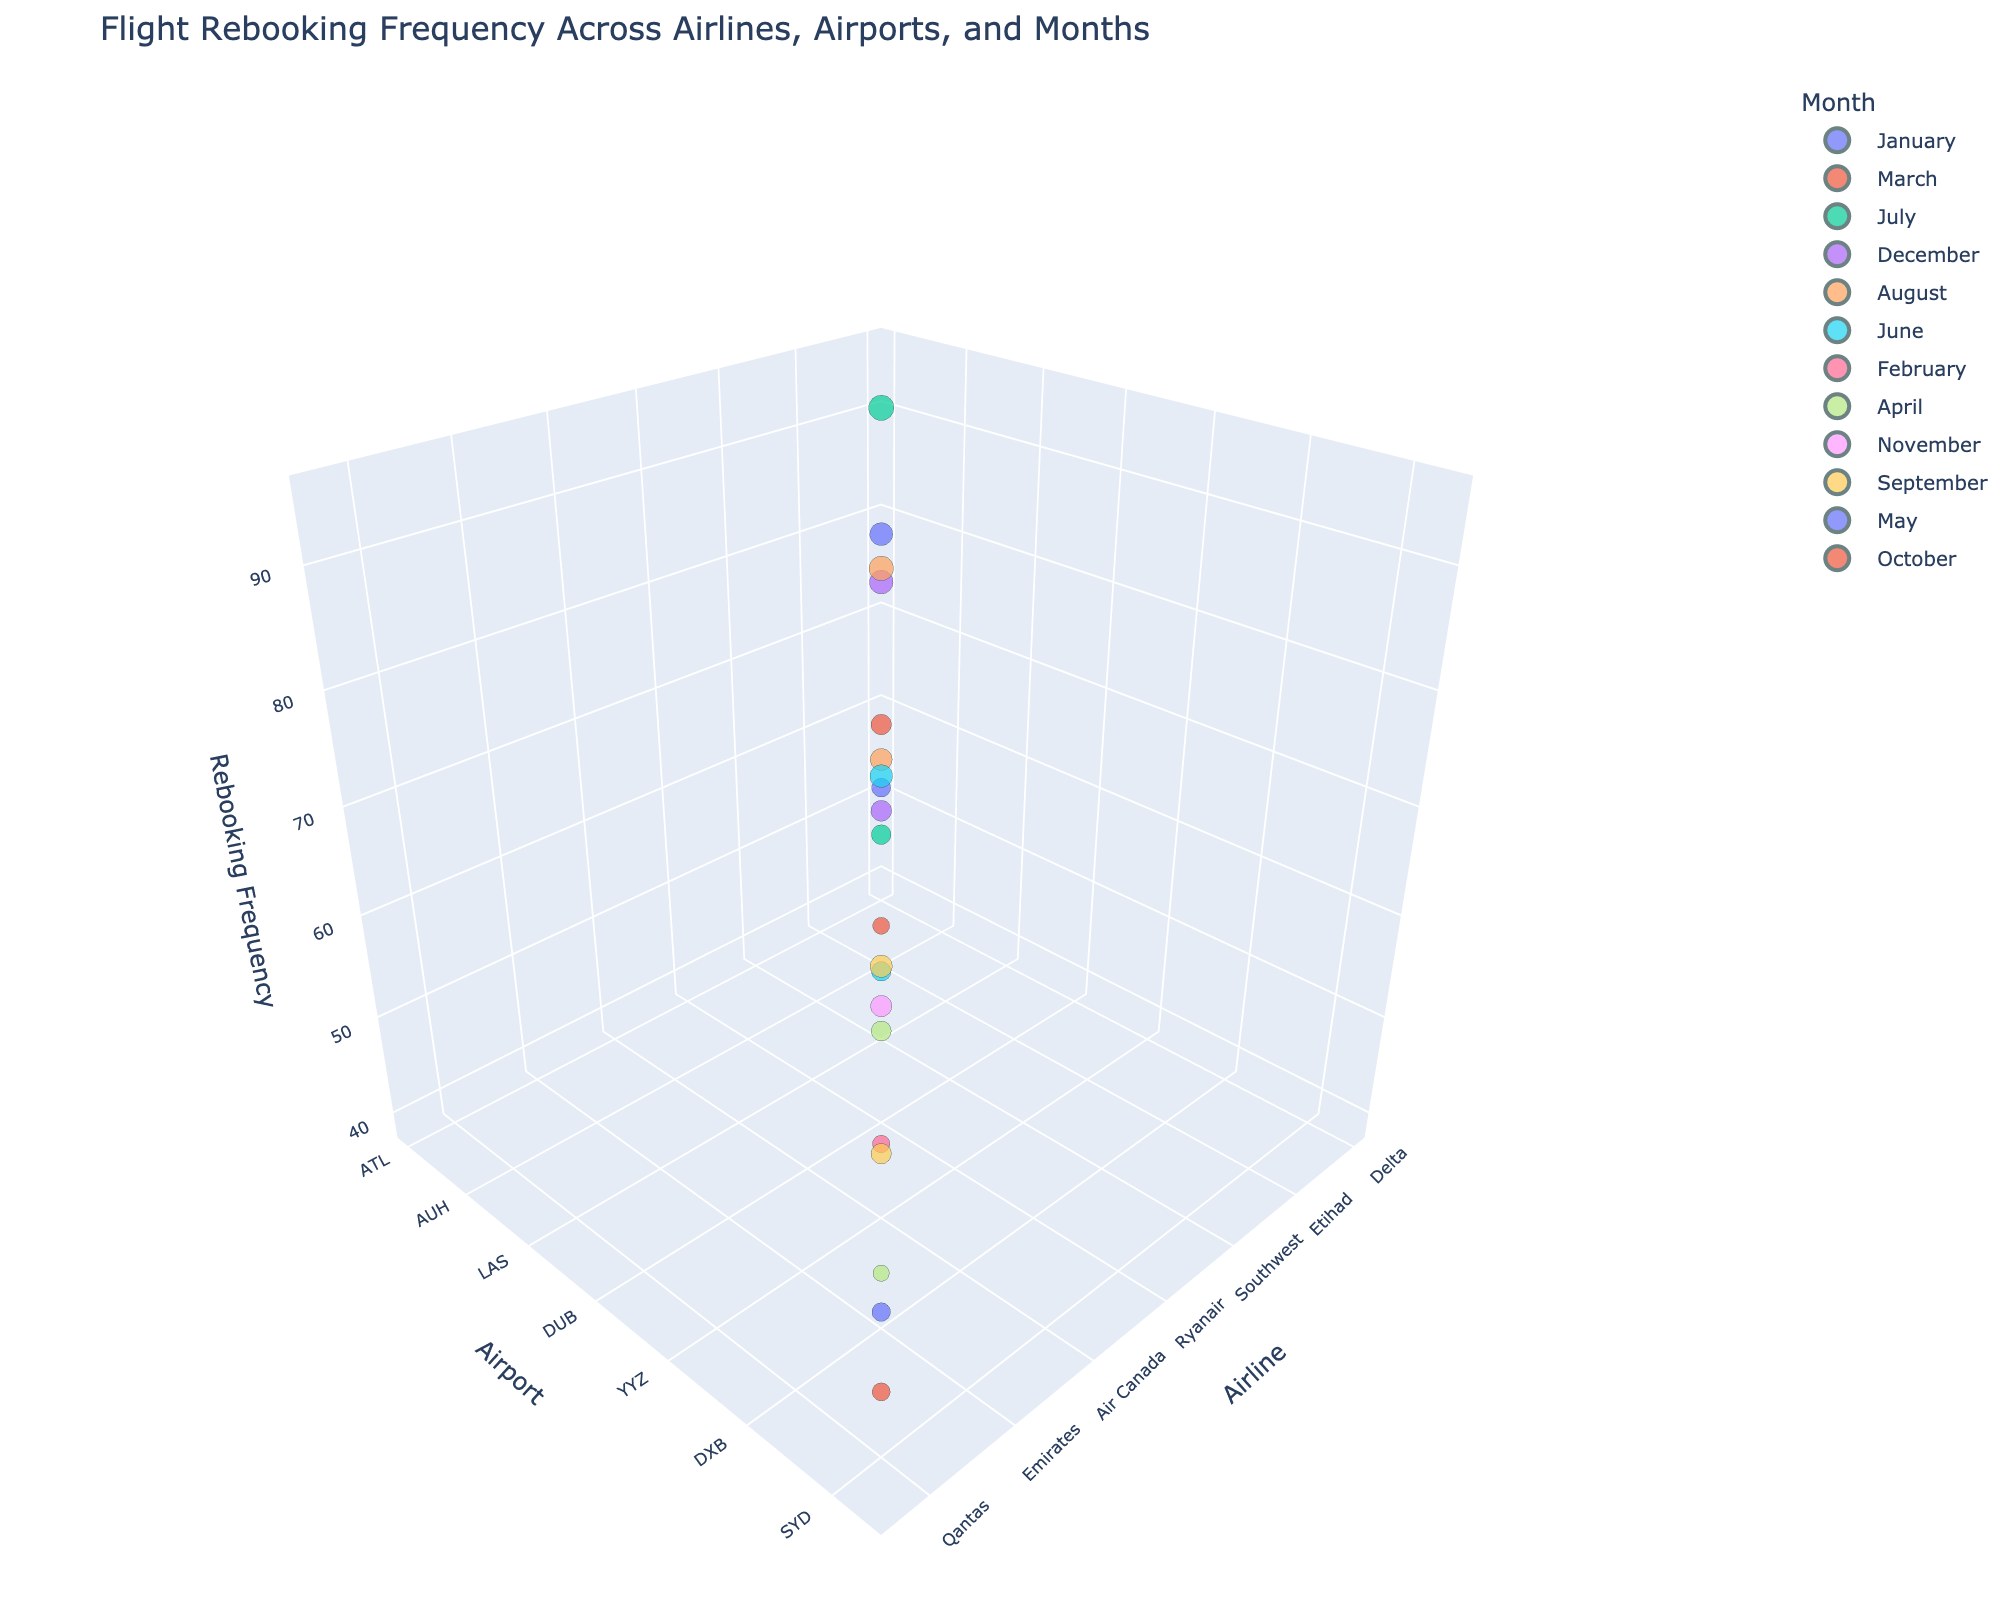How many data points are representing flight rebooking frequencies in the plot? There are 19 rows in the dataset provided, each representing a unique combination of Airline, Airport, Month, and RebookingFrequency. So, there are 19 data points in total in the plot.
Answer: 19 Which airline has the highest rebooking frequency? By inspecting the z-axis (Rebooking Frequency) in the 3D scatter plot, the highest point on this axis represents the highest rebooking frequency. American Airlines has the highest rebooking frequency at 95 in July at DFW Airport.
Answer: American What is the rebooking frequency for Emirates at DXB in November? By locating Emirates on the x-axis, DXB on the y-axis, and adjusting the view to see the z-axis value for November, we find the rebooking frequency is 67.
Answer: 67 Which airline and airport combination shows the lowest rebooking frequency? By looking for the lowest point on the z-axis (Rebooking Frequency), we see that Avianca at BOG Airport in April has the lowest rebooking frequency at 39.
Answer: Avianca at BOG What is the total rebooking frequency for flights operated by Delta and American combined? To find the total rebooking frequency, sum the RebookingFrequency values for Delta (78) and American (95). The total is 78 + 95 = 173.
Answer: 173 Between January and December, which month shows a higher number of airlines with high rebooking frequencies (greater than 70)? By counting the number of airlines with rebooking frequencies greater than 70 for January and December, we find that January has 2 (Delta: 78 and Turkish Airlines: 53), and December has 2 (Southwest: 83 and Air France: 64). Therefore, the numbers are equal.
Answer: Equal Which airport experiences higher rebooking frequency in July, JFK or AMS? Comparing the rebooking frequencies in July, JetBlue at JFK has 71, and KLM at AMS has 57. Therefore, JFK has a higher rebooking frequency.
Answer: JFK Compare the rebooking frequencies of airlines operating at SEA and LGW in June. Which one is higher? Alaska at SEA in June has a rebooking frequency of 56, and EasyJet at LGW in June has 76. So, LGW has a higher rebooking frequency.
Answer: LGW What's the average rebooking frequency for airlines operating out of LHR (British Airways) and DOH (Qatar Airways) in September? To calculate the average, sum the rebooking frequencies for British Airways (73) and Qatar Airways (61), then divide by the number of data points (2). The average is (73 + 61) / 2 = 67.
Answer: 67 Which airline has higher rebooking frequency, Singapore Airlines in October or Ryanair in August? Comparing the rebooking frequencies, Singapore Airlines in October has 48, and Ryanair in August has 89. Ryanair has the higher rebooking frequency.
Answer: Ryanair 